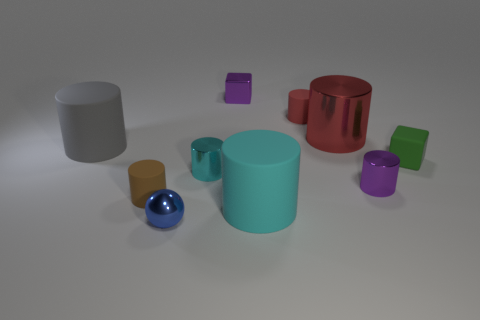Are there the same number of gray rubber cylinders on the right side of the tiny brown rubber cylinder and tiny metal cubes? No, the number is not the same. On the right side of the tiny brown rubber cylinder, there are two gray rubber cylinders, whereas there are three tiny metal cubes positioned separately. 